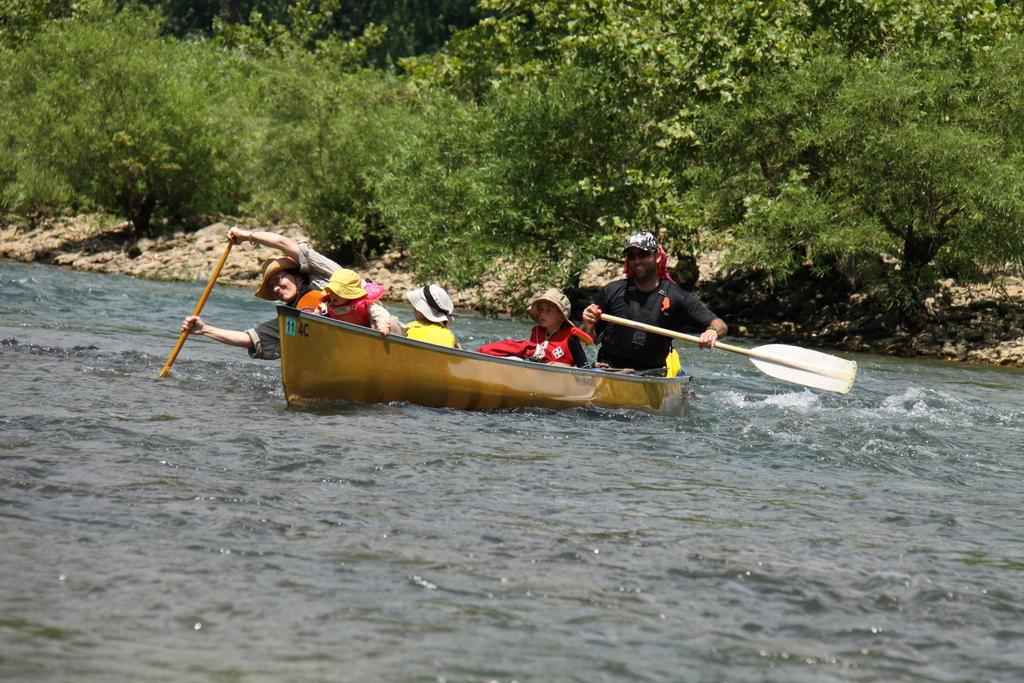How many people are in the image? There are two men and three children in the image, making a total of five people. What are the people doing in the image? The people are sitting in a boat. What color is the boat? The boat is brown in color. Where is the boat located? The boat is on the surface of water. What can be seen in the background of the image? Trees are present in the background of the image. What type of stem can be seen growing from the water in the image? There is no stem growing from the water in the image; it only shows people sitting in a boat on the water's surface. 